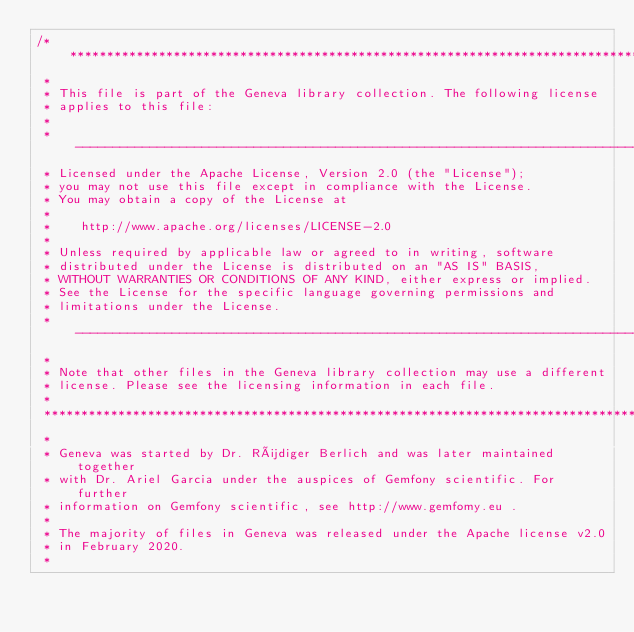<code> <loc_0><loc_0><loc_500><loc_500><_C++_>/********************************************************************************
 *
 * This file is part of the Geneva library collection. The following license
 * applies to this file:
 *
 * ------------------------------------------------------------------------------
 * Licensed under the Apache License, Version 2.0 (the "License");
 * you may not use this file except in compliance with the License.
 * You may obtain a copy of the License at
 *
 *    http://www.apache.org/licenses/LICENSE-2.0
 *
 * Unless required by applicable law or agreed to in writing, software
 * distributed under the License is distributed on an "AS IS" BASIS,
 * WITHOUT WARRANTIES OR CONDITIONS OF ANY KIND, either express or implied.
 * See the License for the specific language governing permissions and
 * limitations under the License.
 * ------------------------------------------------------------------------------
 *
 * Note that other files in the Geneva library collection may use a different
 * license. Please see the licensing information in each file.
 *
 ********************************************************************************
 *
 * Geneva was started by Dr. Rüdiger Berlich and was later maintained together
 * with Dr. Ariel Garcia under the auspices of Gemfony scientific. For further
 * information on Gemfony scientific, see http://www.gemfomy.eu .
 *
 * The majority of files in Geneva was released under the Apache license v2.0
 * in February 2020.
 *</code> 